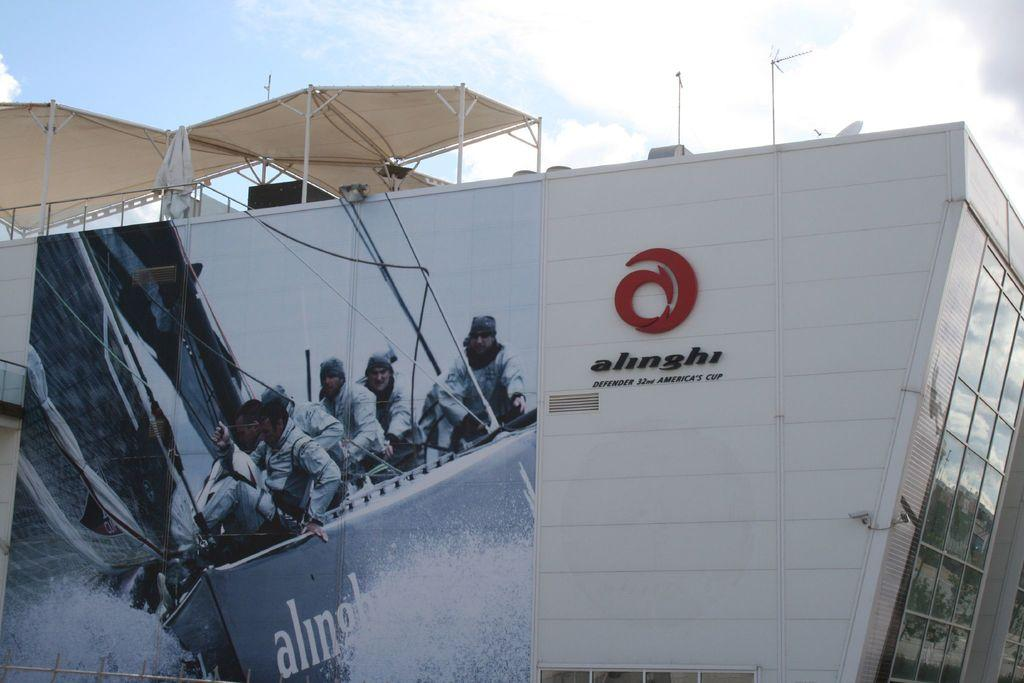What type of structure is visible in the image? There is a building in the image. What is on the building? There is a hoarding on the building. Are there any additional structures on the building? Yes, there are tents on the roof of the building. How many fairies can be seen sitting on the tents in the image? There are no fairies present in the image; it only shows a building with a hoarding and tents on the roof. 